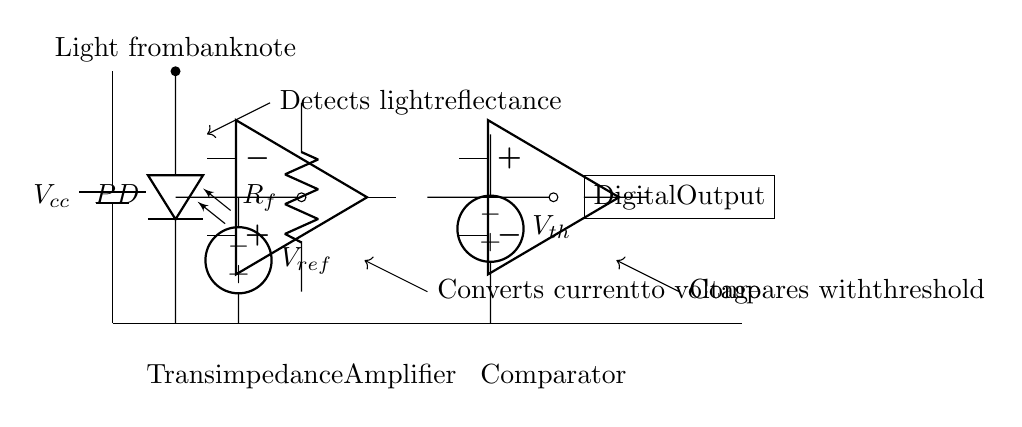What is the reference voltage in the circuit? The reference voltage is denoted as V_ref and is connected to the transimpedance amplifier's output. It provides a comparison level for the comparator.
Answer: V_ref What component converts current to voltage? The transimpedance amplifier is specifically designed to convert the current generated by the photodiode into a voltage. This is essential for detecting changes in light intensity.
Answer: Transimpedance amplifier What is the purpose of the comparator in this circuit? The comparator compares the voltage output from the transimpedance amplifier with the threshold voltage, V_th, to determine if the detected signal indicates counterfeit currency or not.
Answer: Comparison What does the light from the banknote do in this circuit? The light from the banknote is detected by the photodiode, which generates a current proportional to the light intensity reflected from the banknote, initiating the currency verification process.
Answer: Detects light reflectance What is the output type of the comparator? The output of the comparator is indicated as a digital output, which provides a binary signal (high or low) based on whether the detected voltage exceeds the threshold voltage.
Answer: Digital output 